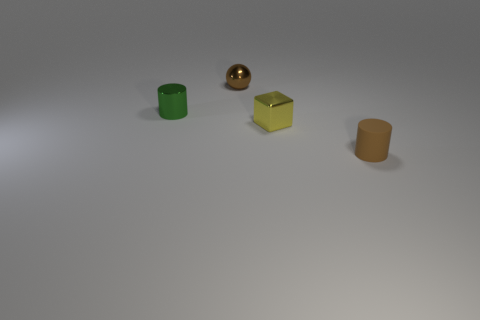Add 3 tiny rubber things. How many objects exist? 7 Subtract 1 cubes. How many cubes are left? 0 Subtract all brown spheres. How many red cylinders are left? 0 Subtract all tiny red metallic balls. Subtract all brown metallic objects. How many objects are left? 3 Add 2 small shiny cylinders. How many small shiny cylinders are left? 3 Add 3 big gray cylinders. How many big gray cylinders exist? 3 Subtract all brown cylinders. How many cylinders are left? 1 Subtract 0 gray cubes. How many objects are left? 4 Subtract all blocks. How many objects are left? 3 Subtract all blue cylinders. Subtract all gray spheres. How many cylinders are left? 2 